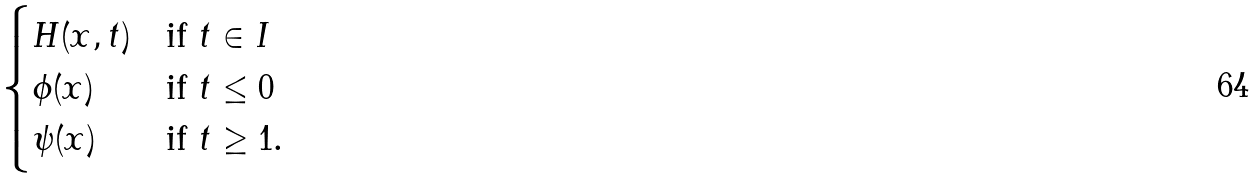Convert formula to latex. <formula><loc_0><loc_0><loc_500><loc_500>\begin{cases} H ( x , t ) & \text {if $t\in I$} \\ \phi ( x ) & \text {if $t\leq0$} \\ \psi ( x ) & \text {if $t\geq1$.} \\ \end{cases}</formula> 